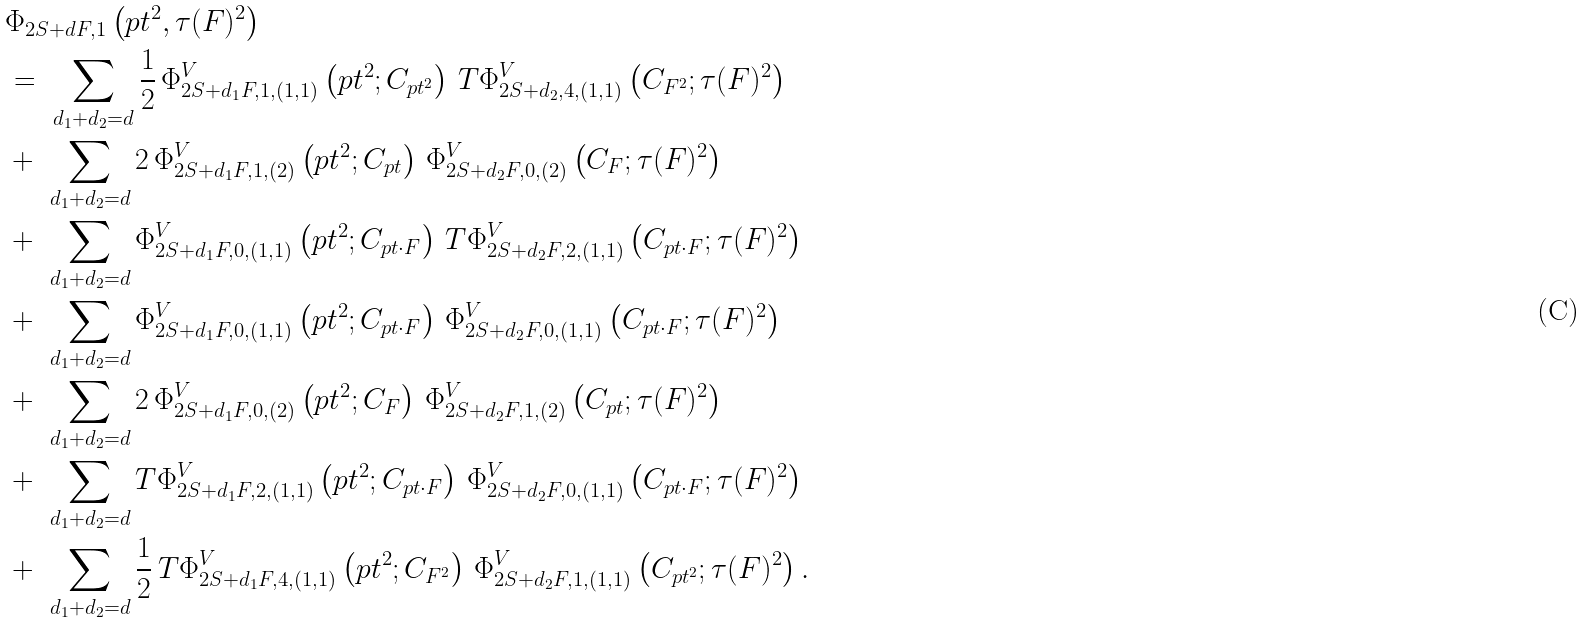<formula> <loc_0><loc_0><loc_500><loc_500>& \Phi _ { 2 S + d F , 1 } \left ( p t ^ { 2 } , \tau ( F ) ^ { 2 } \right ) \\ & = \ \sum _ { d _ { 1 } + d _ { 2 } = d } \frac { 1 } { 2 } \, \Phi _ { 2 S + d _ { 1 } F , 1 , ( 1 , 1 ) } ^ { V } \left ( p t ^ { 2 } ; C _ { p t ^ { 2 } } \right ) \, T \Phi _ { 2 S + d _ { 2 } , 4 , ( 1 , 1 ) } ^ { V } \left ( C _ { F ^ { 2 } } ; \tau ( F ) ^ { 2 } \right ) \\ & + \ \sum _ { d _ { 1 } + d _ { 2 } = d } 2 \, \Phi _ { 2 S + d _ { 1 } F , 1 , ( 2 ) } ^ { V } \left ( p t ^ { 2 } ; C _ { p t } \right ) \, \Phi _ { 2 S + d _ { 2 } F , 0 , ( 2 ) } ^ { V } \left ( C _ { F } ; \tau ( F ) ^ { 2 } \right ) \\ & + \ \sum _ { d _ { 1 } + d _ { 2 } = d } \Phi _ { 2 S + d _ { 1 } F , 0 , ( 1 , 1 ) } ^ { V } \left ( p t ^ { 2 } ; C _ { p t \cdot F } \right ) \, T \Phi _ { 2 S + d _ { 2 } F , 2 , ( 1 , 1 ) } ^ { V } \left ( C _ { p t \cdot F } ; \tau ( F ) ^ { 2 } \right ) \\ & + \ \sum _ { d _ { 1 } + d _ { 2 } = d } \Phi _ { 2 S + d _ { 1 } F , 0 , ( 1 , 1 ) } ^ { V } \left ( p t ^ { 2 } ; C _ { p t \cdot F } \right ) \, \Phi _ { 2 S + d _ { 2 } F , 0 , ( 1 , 1 ) } ^ { V } \left ( C _ { p t \cdot F } ; \tau ( F ) ^ { 2 } \right ) \\ & + \ \sum _ { d _ { 1 } + d _ { 2 } = d } 2 \, \Phi _ { 2 S + d _ { 1 } F , 0 , ( 2 ) } ^ { V } \left ( p t ^ { 2 } ; C _ { F } \right ) \, \Phi _ { 2 S + d _ { 2 } F , 1 , ( 2 ) } ^ { V } \left ( C _ { p t } ; \tau ( F ) ^ { 2 } \right ) \\ & + \ \sum _ { d _ { 1 } + d _ { 2 } = d } T \Phi _ { 2 S + d _ { 1 } F , 2 , ( 1 , 1 ) } ^ { V } \left ( p t ^ { 2 } ; C _ { p t \cdot F } \right ) \, \Phi _ { 2 S + d _ { 2 } F , 0 , ( 1 , 1 ) } ^ { V } \left ( C _ { p t \cdot F } ; \tau ( F ) ^ { 2 } \right ) \\ & + \ \sum _ { d _ { 1 } + d _ { 2 } = d } \frac { 1 } { 2 } \, T \Phi _ { 2 S + d _ { 1 } F , 4 , ( 1 , 1 ) } ^ { V } \left ( p t ^ { 2 } ; C _ { F ^ { 2 } } \right ) \, \Phi _ { 2 S + d _ { 2 } F , 1 , ( 1 , 1 ) } ^ { V } \left ( C _ { p t ^ { 2 } } ; \tau ( F ) ^ { 2 } \right ) .</formula> 